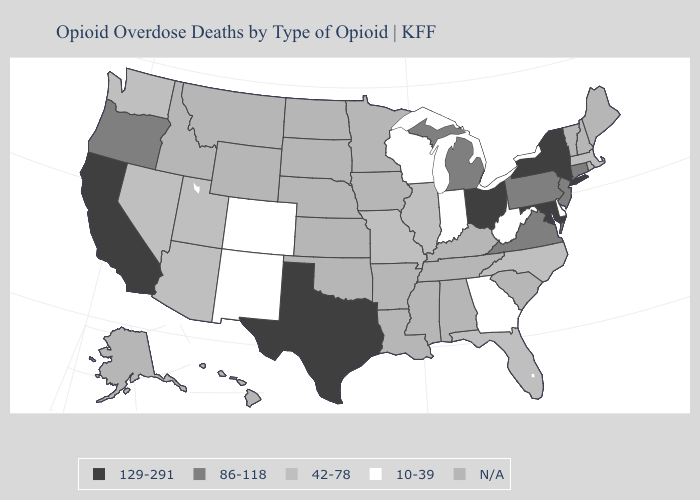Name the states that have a value in the range 42-78?
Write a very short answer. Arizona, Florida, Illinois, Massachusetts, Missouri, Nevada, North Carolina, Utah, Washington. Does Massachusetts have the highest value in the Northeast?
Short answer required. No. What is the highest value in the USA?
Answer briefly. 129-291. What is the value of California?
Give a very brief answer. 129-291. Name the states that have a value in the range 129-291?
Give a very brief answer. California, Maryland, New York, Ohio, Texas. Does Oregon have the lowest value in the USA?
Keep it brief. No. What is the value of Michigan?
Write a very short answer. 86-118. What is the value of New Hampshire?
Keep it brief. N/A. What is the value of Virginia?
Concise answer only. 86-118. Is the legend a continuous bar?
Give a very brief answer. No. What is the value of Tennessee?
Give a very brief answer. N/A. What is the value of California?
Concise answer only. 129-291. What is the value of Florida?
Be succinct. 42-78. Name the states that have a value in the range 10-39?
Give a very brief answer. Colorado, Delaware, Georgia, Indiana, New Mexico, West Virginia, Wisconsin. 